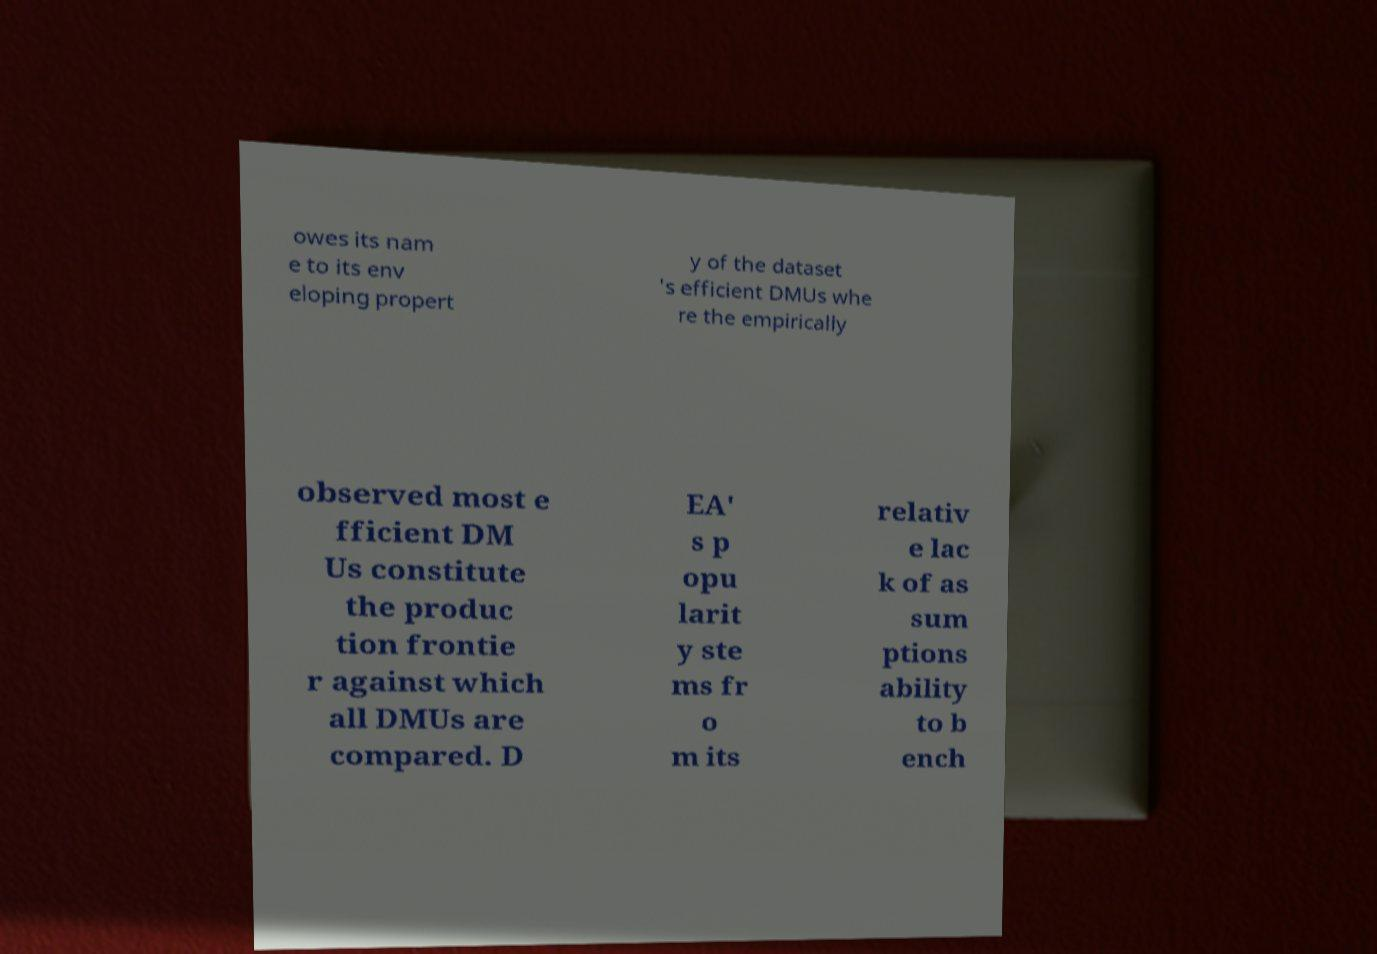Please read and relay the text visible in this image. What does it say? owes its nam e to its env eloping propert y of the dataset 's efficient DMUs whe re the empirically observed most e fficient DM Us constitute the produc tion frontie r against which all DMUs are compared. D EA' s p opu larit y ste ms fr o m its relativ e lac k of as sum ptions ability to b ench 